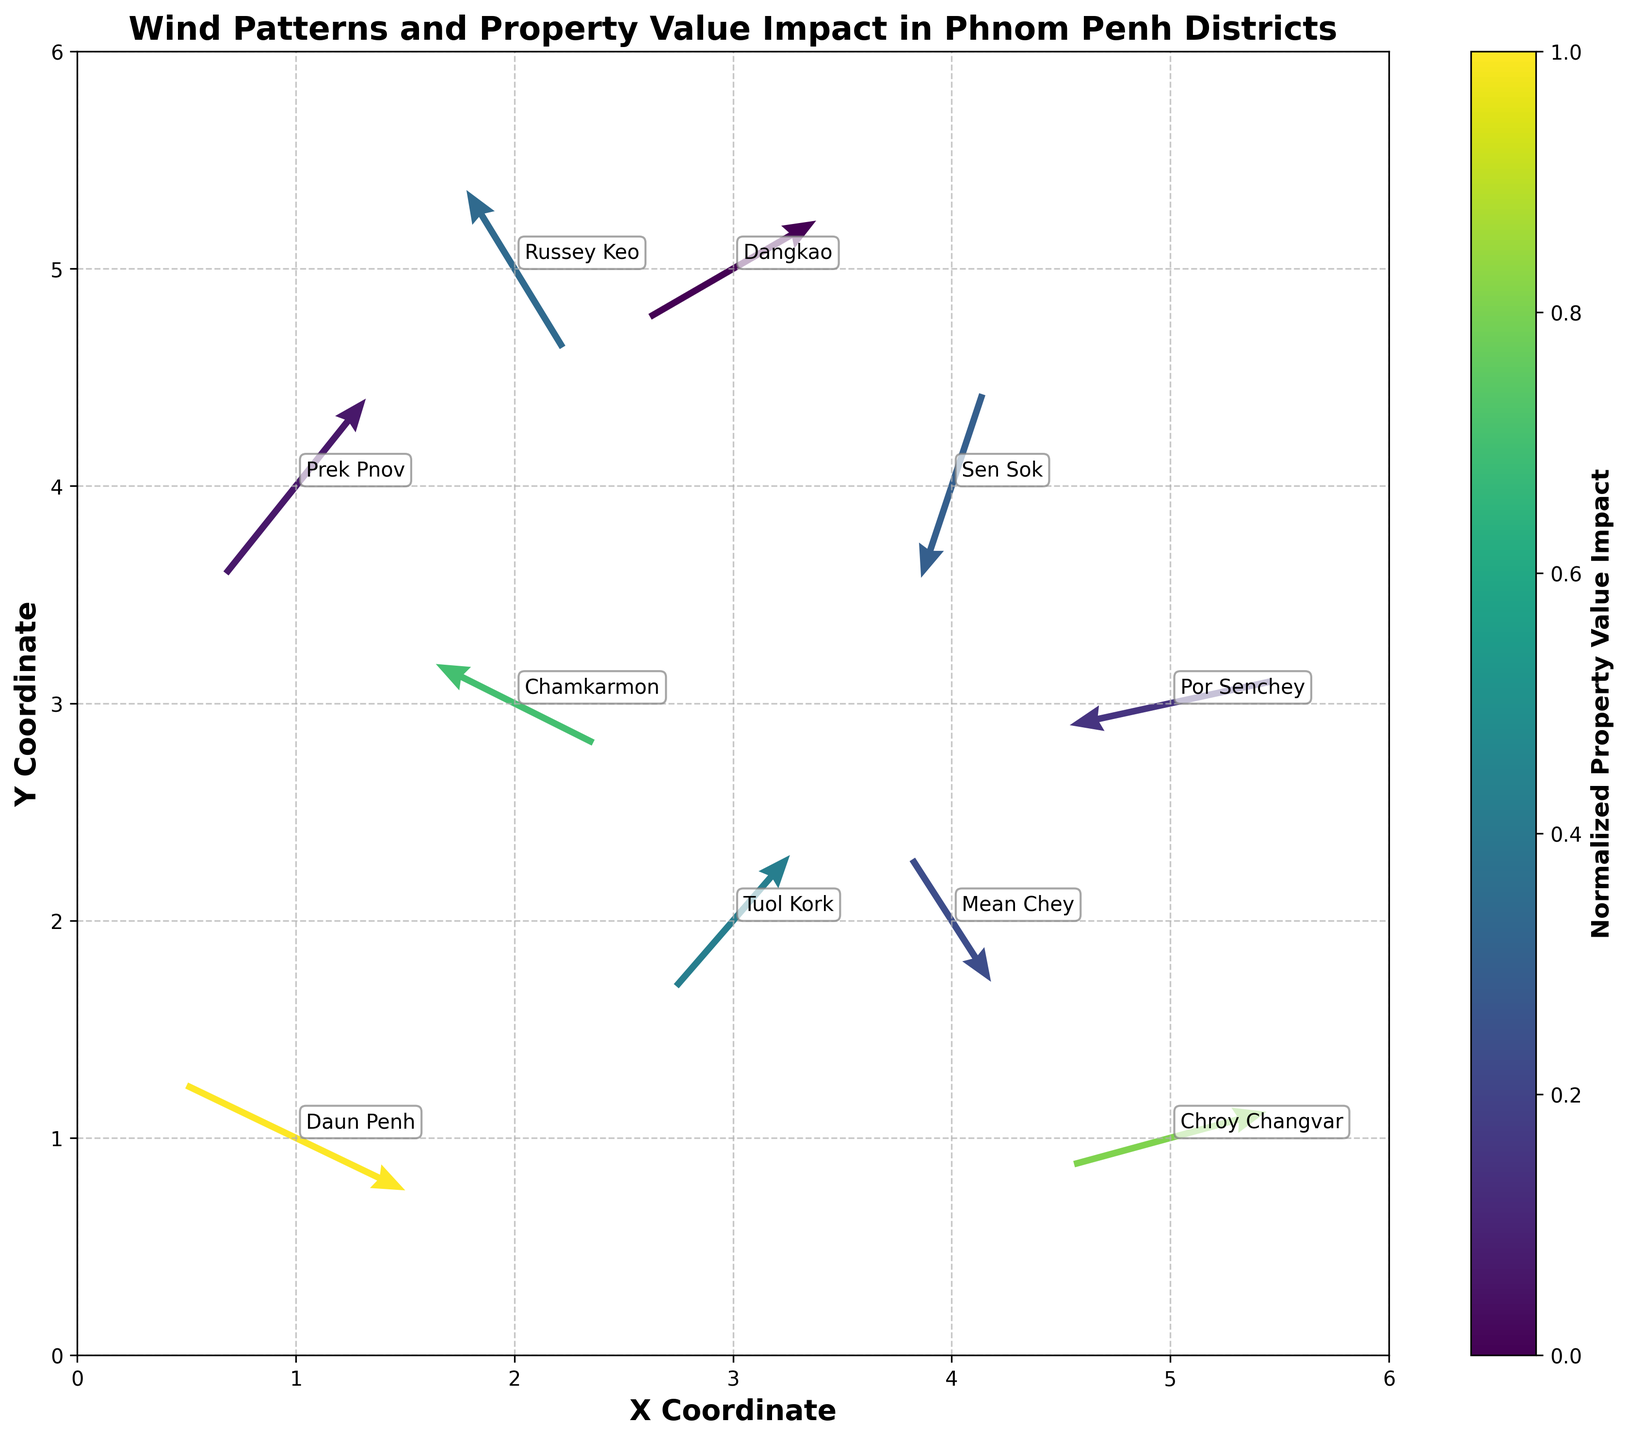What is the title of the plot? The title is displayed at the top of the plot in bold, indicating the main subject of the figure. It reads "Wind Patterns and Property Value Impact in Phnom Penh Districts".
Answer: Wind Patterns and Property Value Impact in Phnom Penh Districts Which axis on the plot indicates the X Coordinates? The X-axis is labeled at the bottom of the plot. It is marked as 'X Coordinate' in bold.
Answer: X Coordinate What does the color of the arrows represent? The color of the arrows corresponds to the normalized property value impact, as indicated by the color bar next to the plot.
Answer: Normalized property value impact In which district is the wind blowing towards the southeast? To find this, identify the arrow pointing towards the southeast (downwards and to the right). In the plot, the arrow at Mean Chey points towards the southeast.
Answer: Mean Chey How does the wind direction in Tuol Kork compare to that in Chroy Changvar? To compare, look at the arrows for these districts. In Tuol Kork, the wind is blowing upwards to the right (northeast), while in Chroy Changvar, it is blowing mainly to the right (eastward) with a slight upward component.
Answer: Tuol Kork: Northeast, Chroy Changvar: Eastwards with slight upward Which district has the highest property value impact and what is its normalized impact color? Look at the district with the highest value in the color bar and its color on the plot. Daun Penh has the highest property value impact of 7.2, which corresponds to the darkest color on the plot.
Answer: Daun Penh, darkest color How many districts show wind patterns with a southward component? Count the arrows pointing either directly down or with a downward component. These include Daun Penh, Sen Sok, Mean Chey, and Por Senchey.
Answer: Four districts Which district experiences the strongest westward wind, and what is its property value impact? Observe arrows with the most significant westward component (leftward direction). Chamkarmon has the strongest westward wind (-1.8) and an impact of 5.8.
Answer: Chamkarmon, 5.8 If you sum up the property value impacts of Por Senchey and Dangkao, what is the result? Add the property value impacts of Por Senchey (3.2) and Dangkao (2.5). 3.2 + 2.5 = 5.7
Answer: 5.7 Which two districts have winds moving directly towards the east and what are their impacts on property values? Identify arrows pointing directly right (east). The districts are Chroy Changvar (6.3) and Russey Keo (4.1).
Answer: Chroy Changvar and Russey Keo, 6.3 and 4.1 